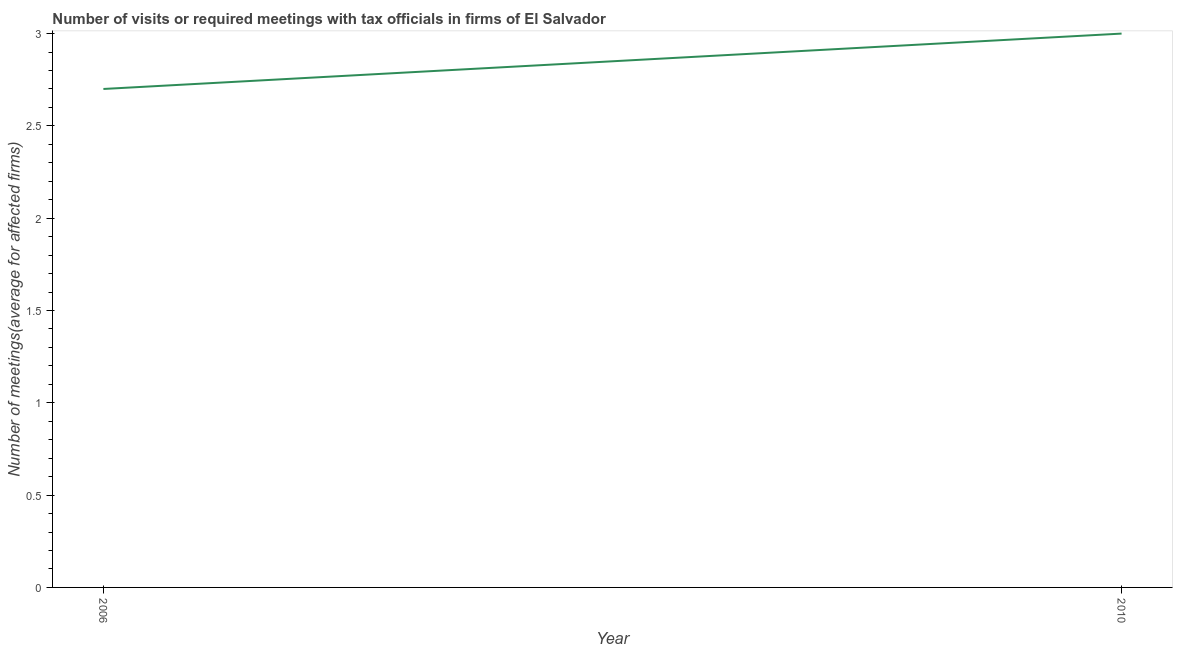What is the number of required meetings with tax officials in 2010?
Make the answer very short. 3. In which year was the number of required meetings with tax officials maximum?
Provide a succinct answer. 2010. What is the difference between the number of required meetings with tax officials in 2006 and 2010?
Give a very brief answer. -0.3. What is the average number of required meetings with tax officials per year?
Your answer should be very brief. 2.85. What is the median number of required meetings with tax officials?
Offer a very short reply. 2.85. What is the ratio of the number of required meetings with tax officials in 2006 to that in 2010?
Provide a short and direct response. 0.9. Is the number of required meetings with tax officials in 2006 less than that in 2010?
Give a very brief answer. Yes. Does the number of required meetings with tax officials monotonically increase over the years?
Give a very brief answer. Yes. How many years are there in the graph?
Your answer should be very brief. 2. Does the graph contain any zero values?
Provide a short and direct response. No. Does the graph contain grids?
Your answer should be compact. No. What is the title of the graph?
Your response must be concise. Number of visits or required meetings with tax officials in firms of El Salvador. What is the label or title of the Y-axis?
Provide a succinct answer. Number of meetings(average for affected firms). What is the difference between the Number of meetings(average for affected firms) in 2006 and 2010?
Your answer should be compact. -0.3. What is the ratio of the Number of meetings(average for affected firms) in 2006 to that in 2010?
Your answer should be compact. 0.9. 